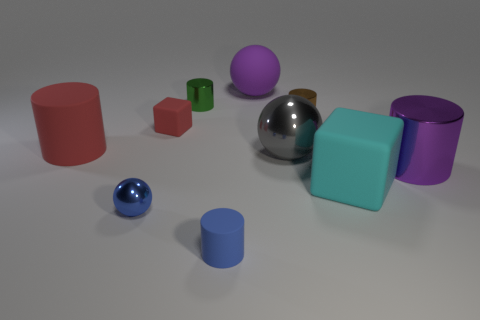Subtract all big balls. How many balls are left? 1 Subtract all brown cylinders. How many cylinders are left? 4 Subtract 3 cylinders. How many cylinders are left? 2 Subtract all spheres. How many objects are left? 7 Subtract all cyan blocks. Subtract all cyan spheres. How many blocks are left? 1 Subtract all gray spheres. Subtract all small metallic spheres. How many objects are left? 8 Add 2 small green cylinders. How many small green cylinders are left? 3 Add 5 large purple rubber things. How many large purple rubber things exist? 6 Subtract 0 brown blocks. How many objects are left? 10 